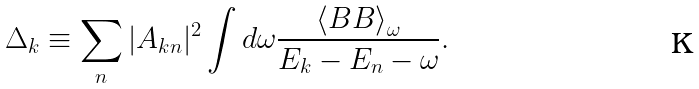Convert formula to latex. <formula><loc_0><loc_0><loc_500><loc_500>\Delta _ { k } \equiv \sum _ { n } | A _ { k n } | ^ { 2 } \int d \omega \frac { \left \langle B B \right \rangle _ { \omega } } { E _ { k } - E _ { n } - \omega } .</formula> 